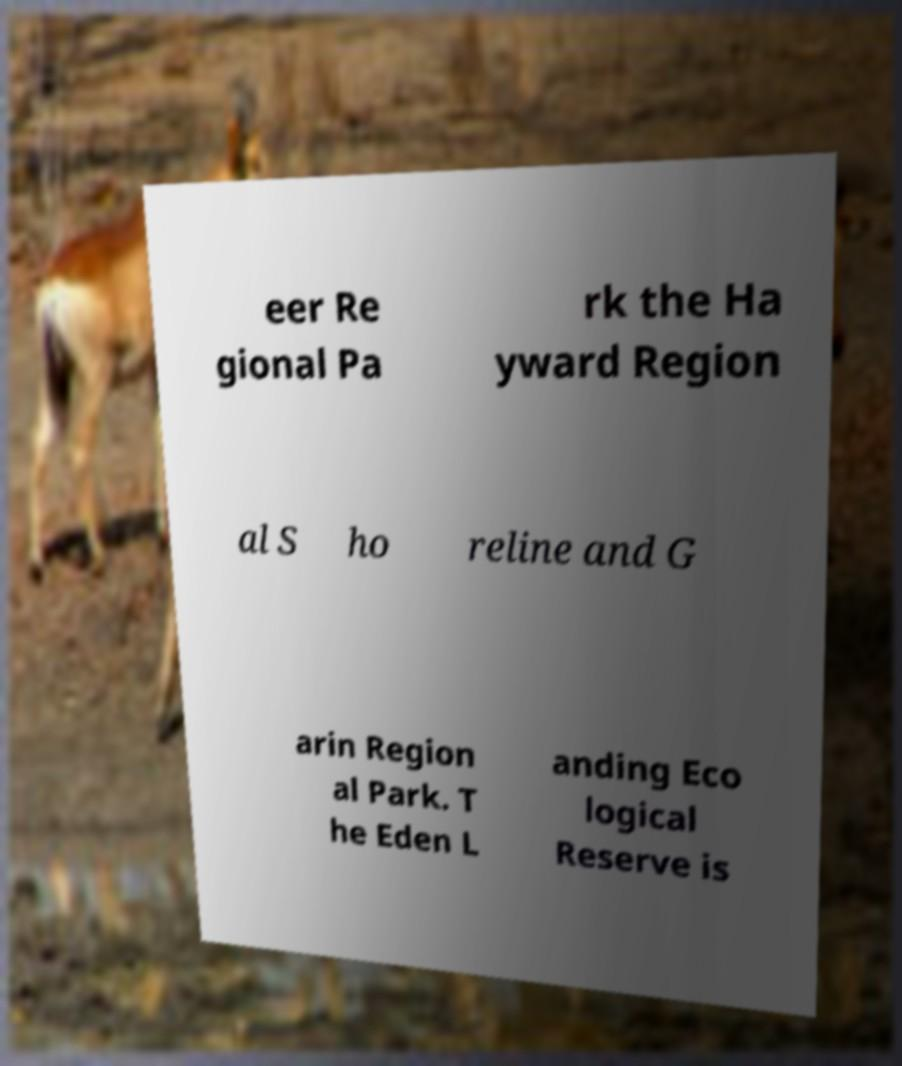Can you accurately transcribe the text from the provided image for me? eer Re gional Pa rk the Ha yward Region al S ho reline and G arin Region al Park. T he Eden L anding Eco logical Reserve is 